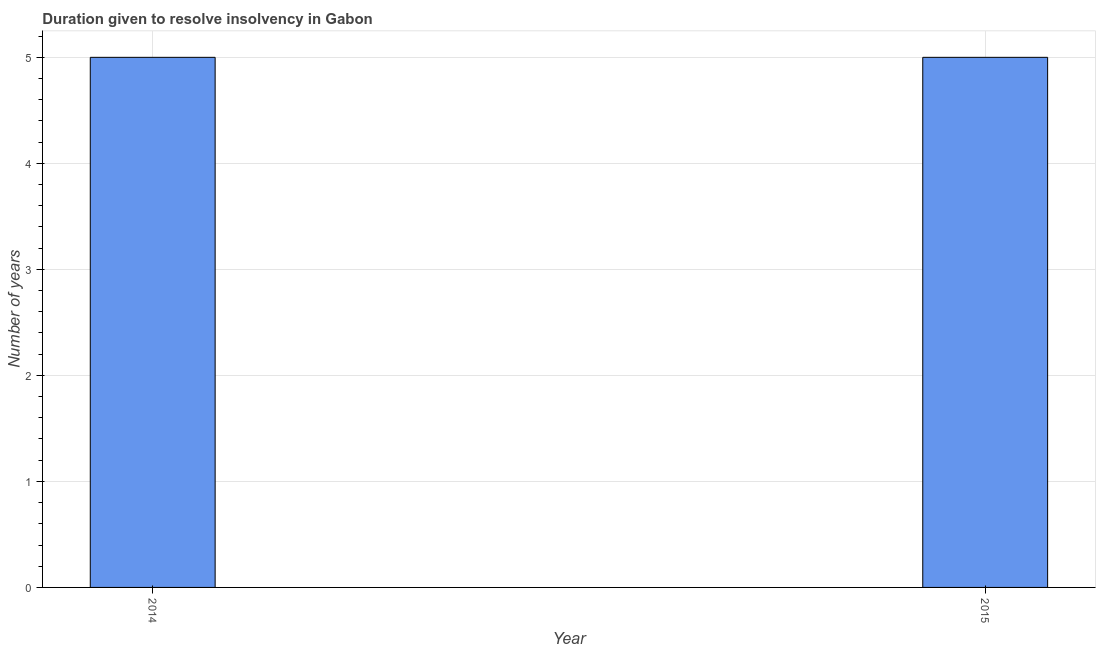Does the graph contain any zero values?
Your answer should be very brief. No. What is the title of the graph?
Your answer should be compact. Duration given to resolve insolvency in Gabon. What is the label or title of the Y-axis?
Give a very brief answer. Number of years. What is the number of years to resolve insolvency in 2014?
Offer a terse response. 5. What is the sum of the number of years to resolve insolvency?
Your response must be concise. 10. Do a majority of the years between 2015 and 2014 (inclusive) have number of years to resolve insolvency greater than 1.6 ?
Provide a short and direct response. No. How many bars are there?
Give a very brief answer. 2. How many years are there in the graph?
Keep it short and to the point. 2. What is the difference between two consecutive major ticks on the Y-axis?
Keep it short and to the point. 1. What is the Number of years in 2014?
Your answer should be compact. 5. 